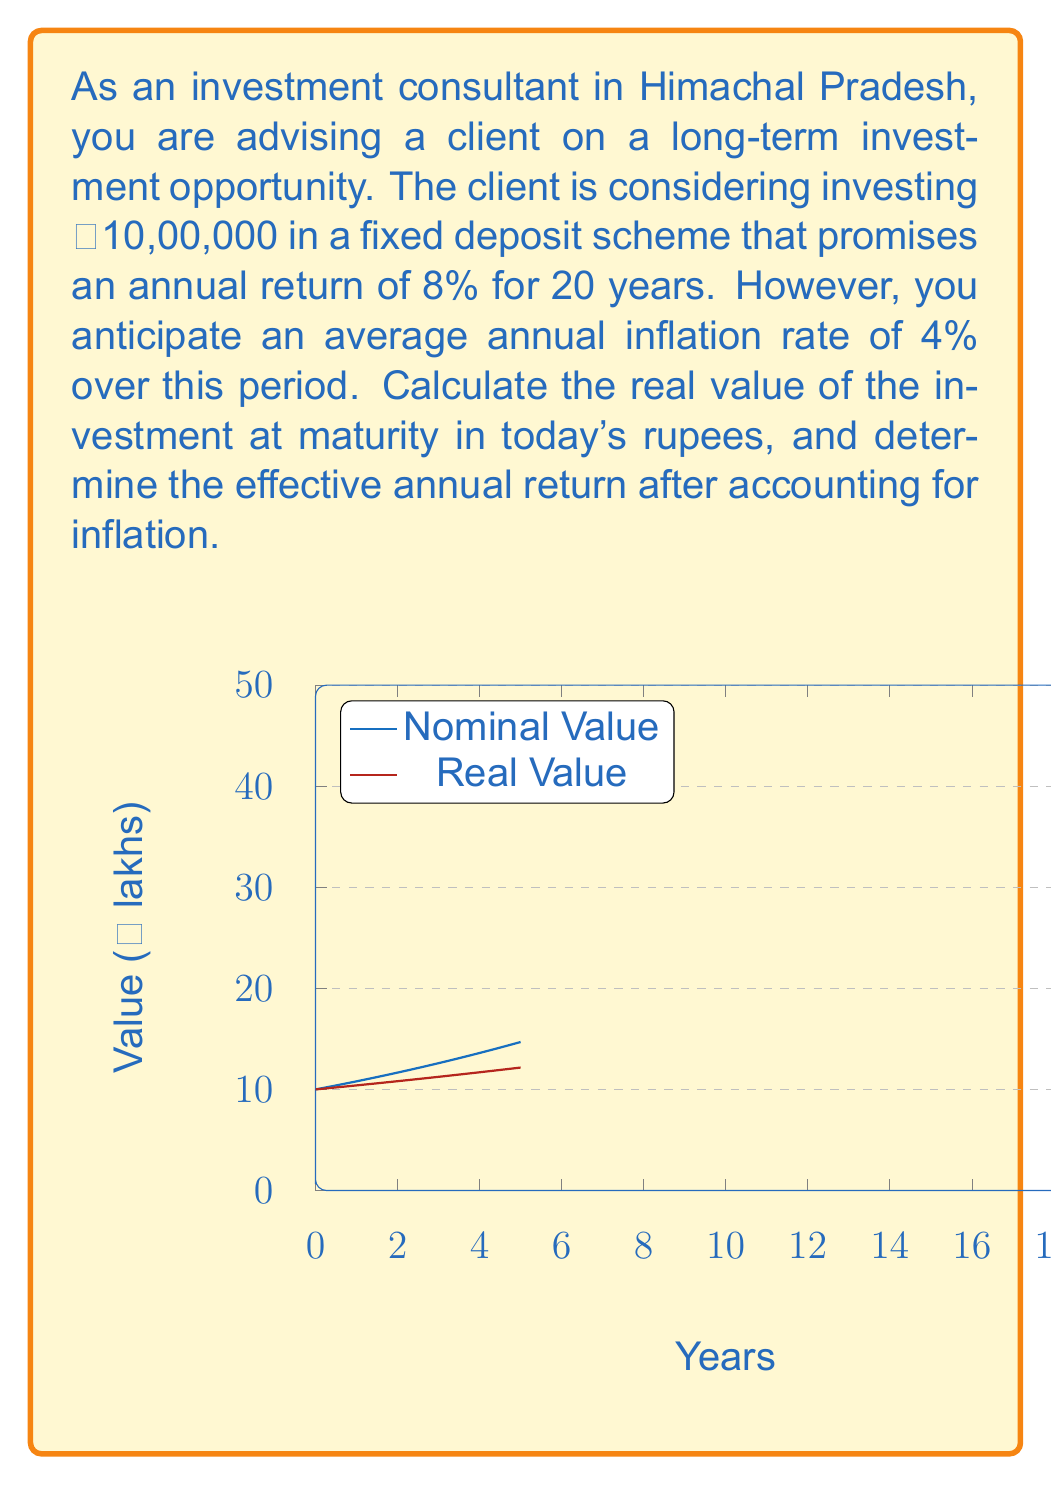Can you solve this math problem? Let's approach this problem step-by-step:

1) First, let's calculate the nominal value of the investment after 20 years:
   $$FV = P(1+r)^n$$
   Where FV is future value, P is principal, r is interest rate, and n is number of years.
   $$FV = 10,00,000 \times (1 + 0.08)^{20} = ₹46,60,957.18$$

2) Now, we need to account for inflation. We can use the present value formula:
   $$PV = \frac{FV}{(1+i)^n}$$
   Where PV is present value, FV is future value, i is inflation rate, and n is number of years.
   $$PV = \frac{46,60,957.18}{(1 + 0.04)^{20}} = ₹21,31,790.33$$

3) To calculate the effective annual return after inflation, we can use the compound annual growth rate (CAGR) formula:
   $$CAGR = \left(\frac{FV}{P}\right)^{\frac{1}{n}} - 1$$
   Where FV is the inflation-adjusted future value (our PV from step 2), P is the initial principal, and n is the number of years.
   $$CAGR = \left(\frac{21,31,790.33}{10,00,000}\right)^{\frac{1}{20}} - 1 = 0.0385 = 3.85\%$$

This means that while the nominal return is 8%, the real return after accounting for inflation is approximately 3.85%.
Answer: Real value after 20 years: ₹21,31,790.33; Effective annual return: 3.85% 